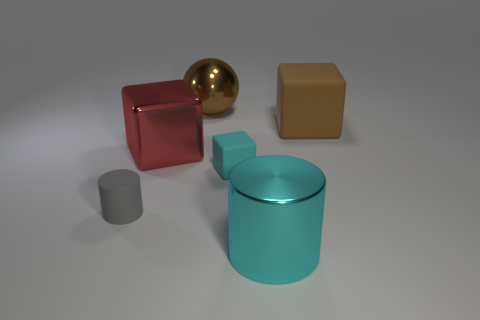Add 2 small things. How many objects exist? 8 Subtract all cylinders. How many objects are left? 4 Add 1 large red rubber balls. How many large red rubber balls exist? 1 Subtract 0 purple cylinders. How many objects are left? 6 Subtract all big shiny cylinders. Subtract all metallic spheres. How many objects are left? 4 Add 2 small matte things. How many small matte things are left? 4 